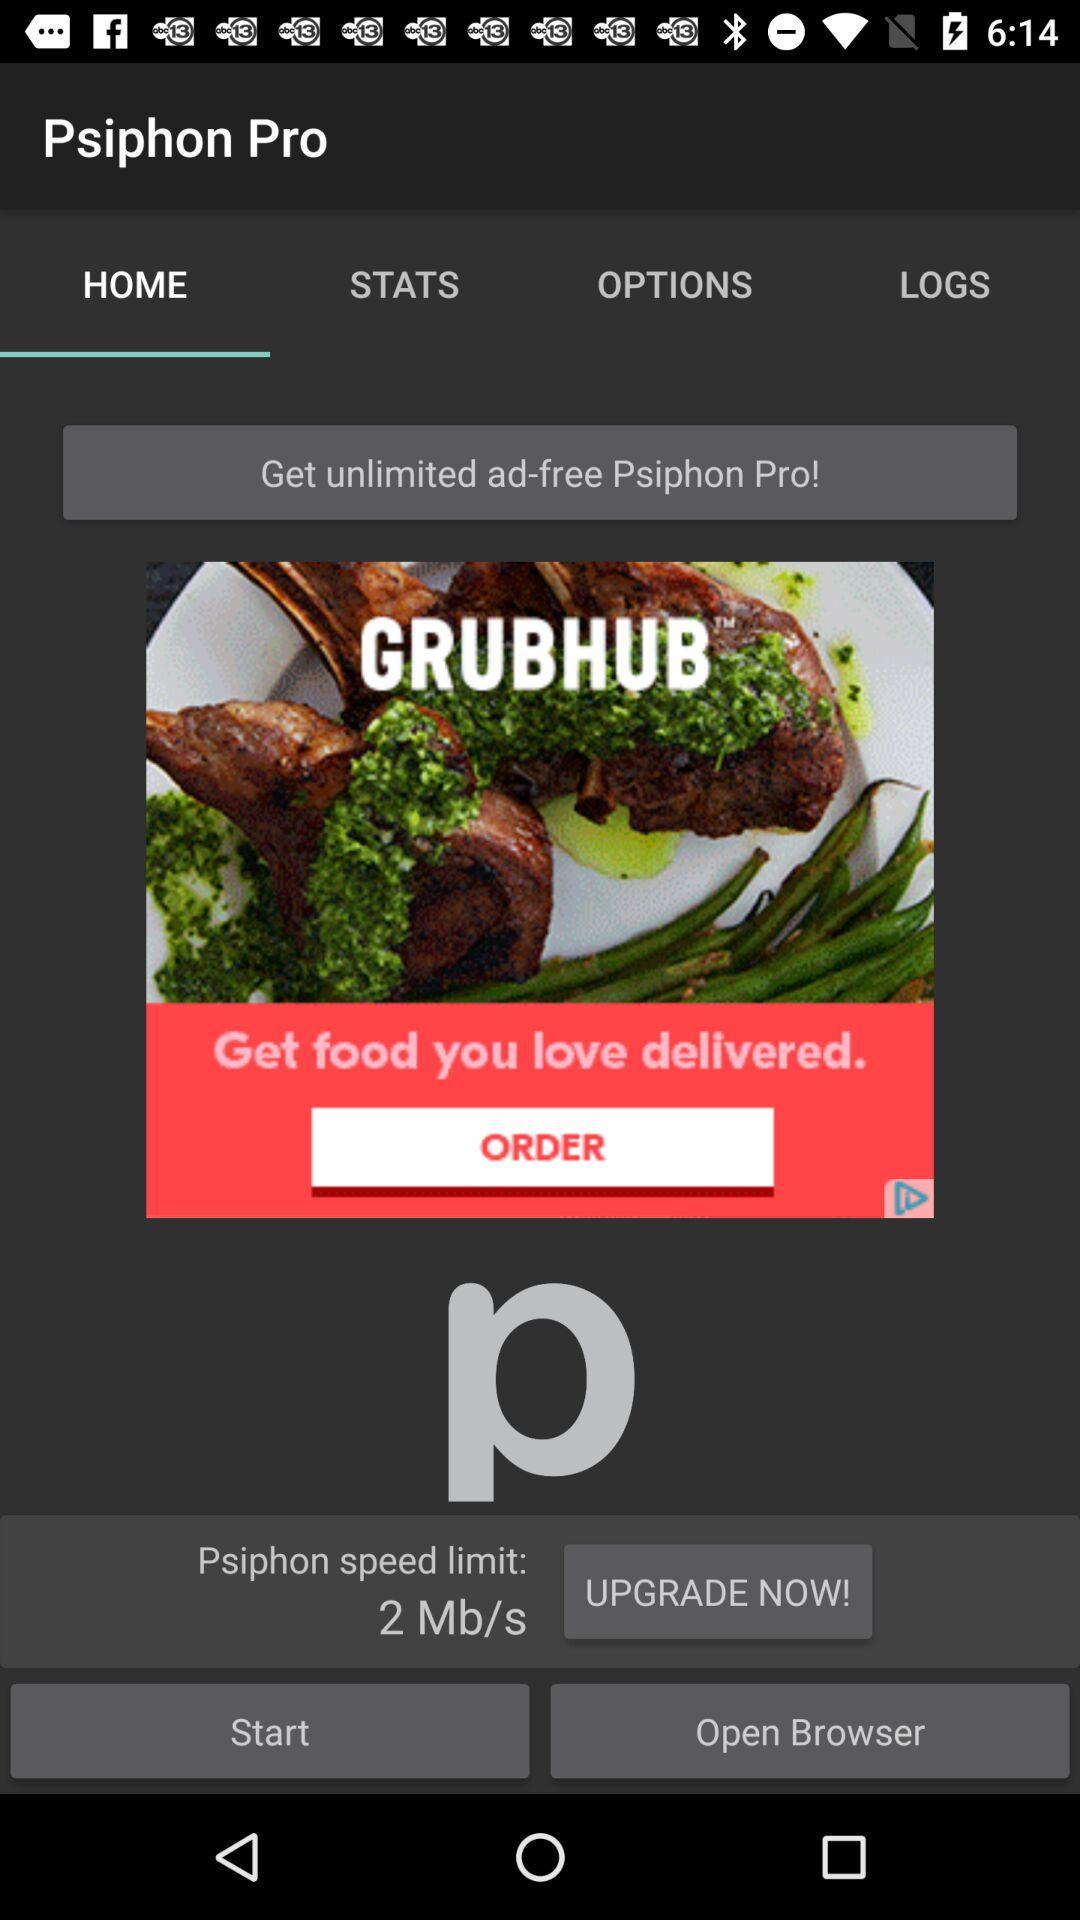Which tab am I using? You are using the "HOME" tab. 